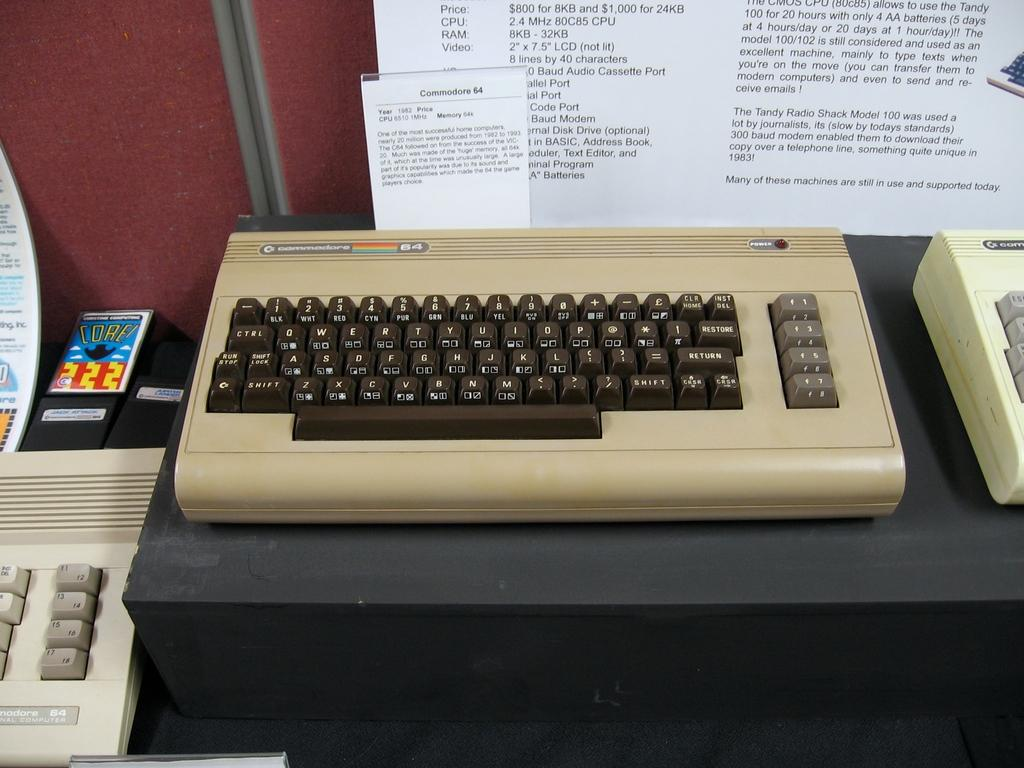<image>
Relay a brief, clear account of the picture shown. A commodore 64 sits on display below an information card detailing its specs. 